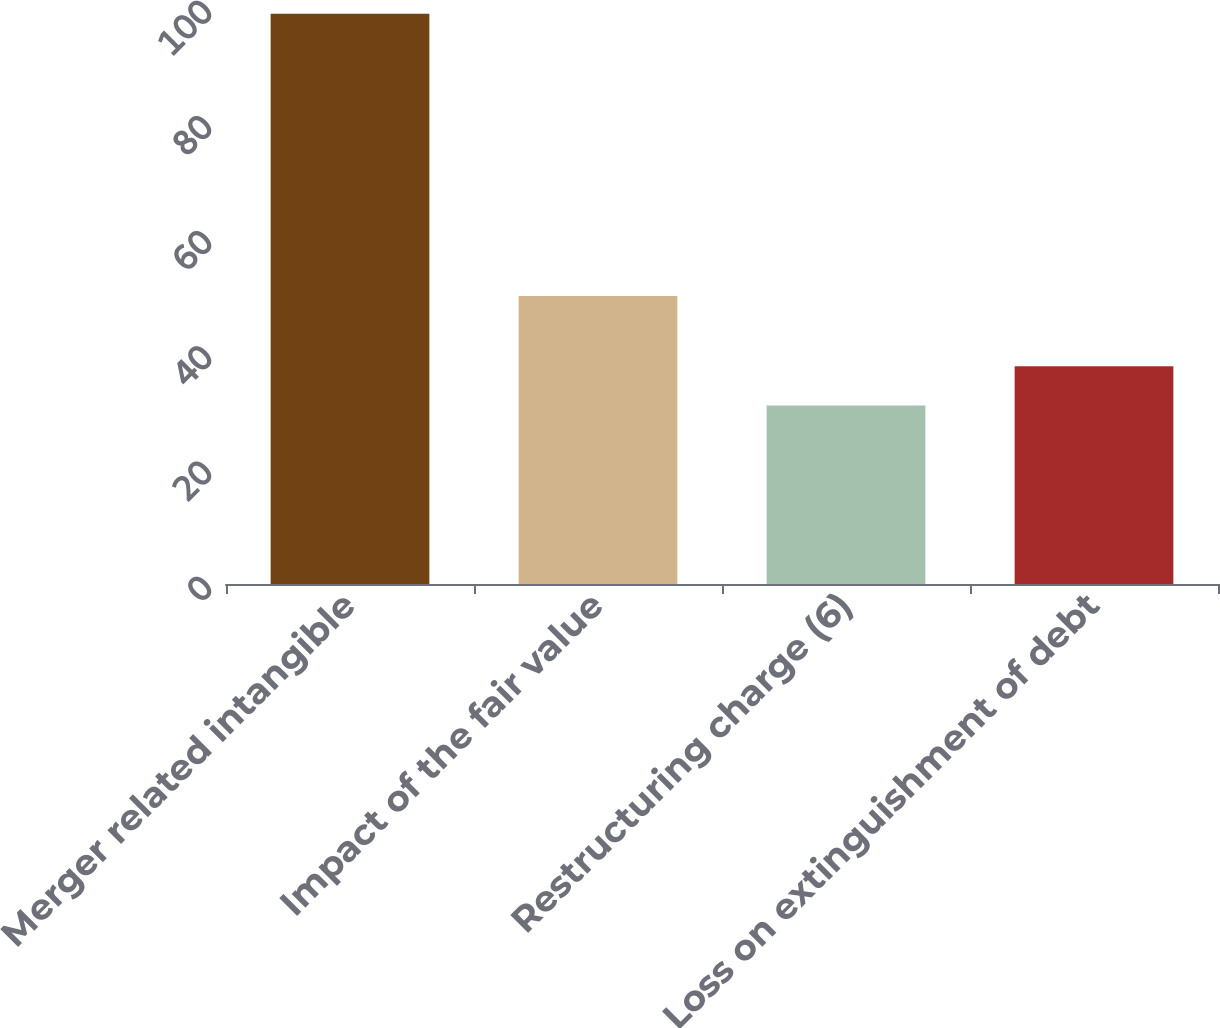<chart> <loc_0><loc_0><loc_500><loc_500><bar_chart><fcel>Merger related intangible<fcel>Impact of the fair value<fcel>Restructuring charge (6)<fcel>Loss on extinguishment of debt<nl><fcel>99<fcel>50<fcel>31<fcel>37.8<nl></chart> 